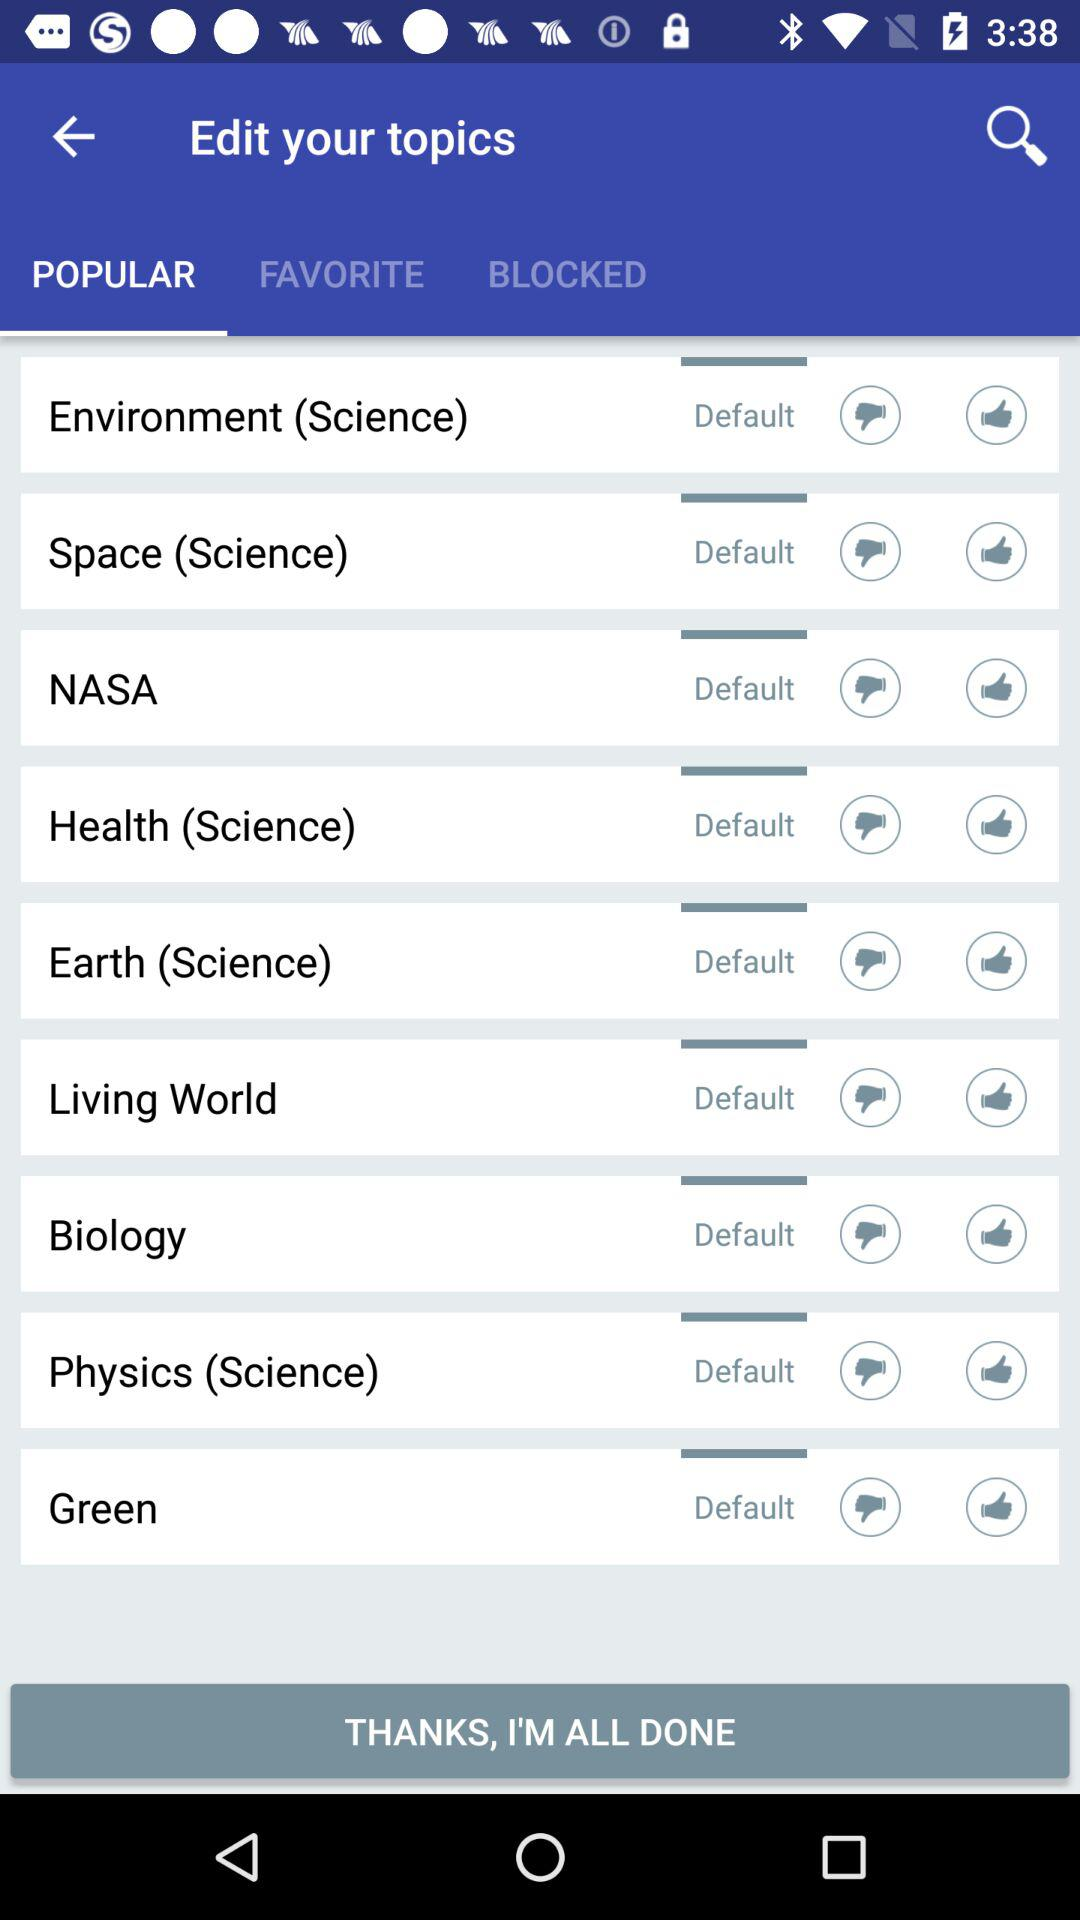Which tab is selected? The selected tab is "POPULAR". 